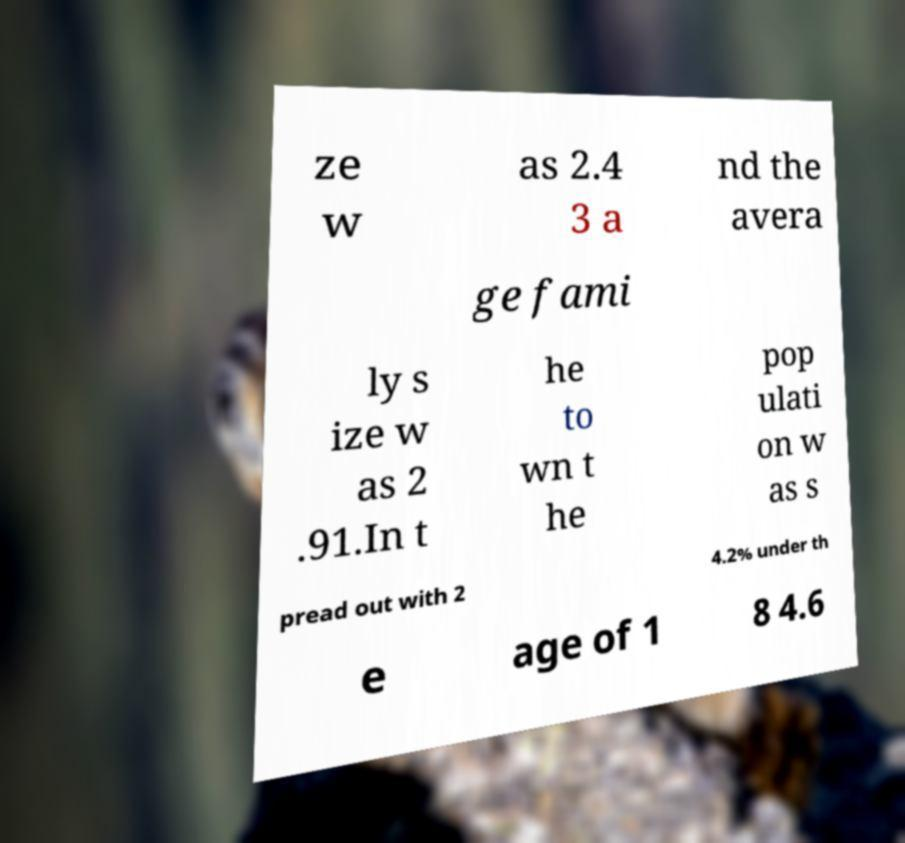What messages or text are displayed in this image? I need them in a readable, typed format. ze w as 2.4 3 a nd the avera ge fami ly s ize w as 2 .91.In t he to wn t he pop ulati on w as s pread out with 2 4.2% under th e age of 1 8 4.6 